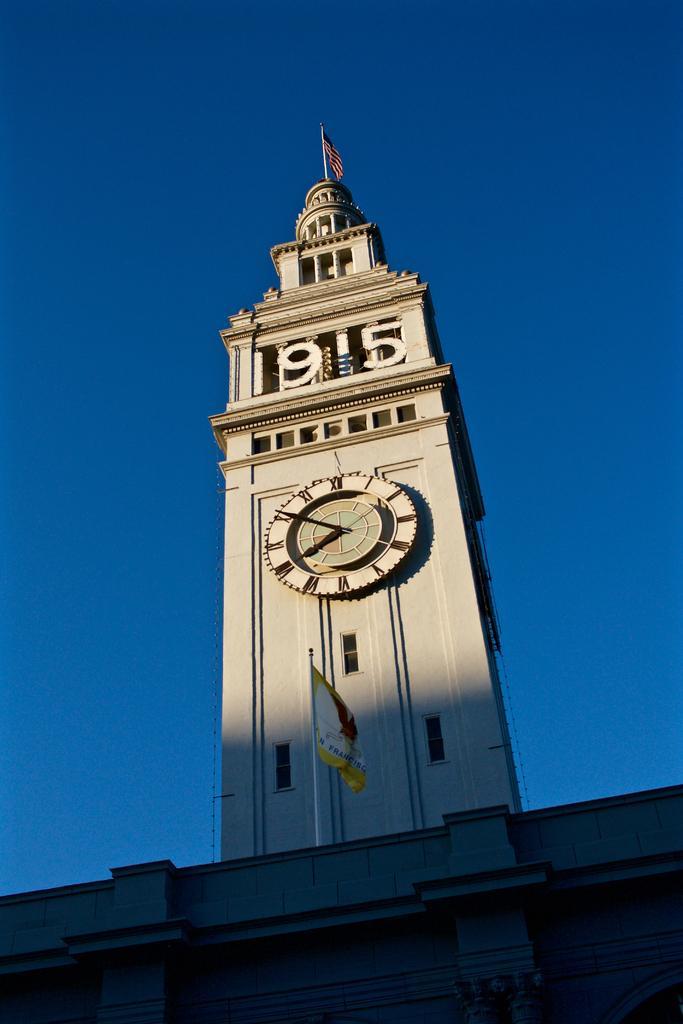Could you give a brief overview of what you see in this image? In this picture we can see a building, there is a clock tower in the middle, we can see a clock and two flags, there is the sky at the top of the picture. 